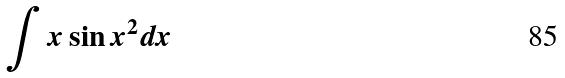Convert formula to latex. <formula><loc_0><loc_0><loc_500><loc_500>\int x \sin x ^ { 2 } d x</formula> 